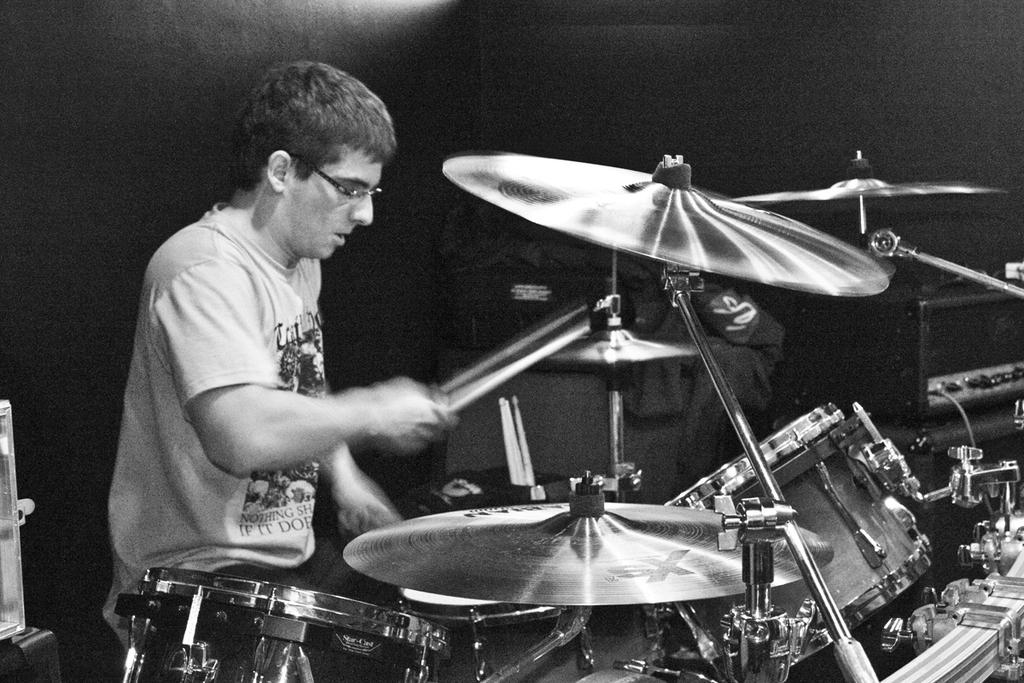What is the main subject of the image? The main subject of the image is a man. What is the man wearing in the image? The man is wearing a t-shirt in the image. What activity is the man engaged in? The man is playing drums in the image. What other musical instrument can be seen in the image? There are cymbals in the image. What accessory is the man wearing in the image? The man is wearing spectacles in the image. What is the color of the background in the image? The background of the image is black in color. What type of apparel is the man using to join the cymbals together in the image? There is no apparel or action of joining cymbals together in the image. 